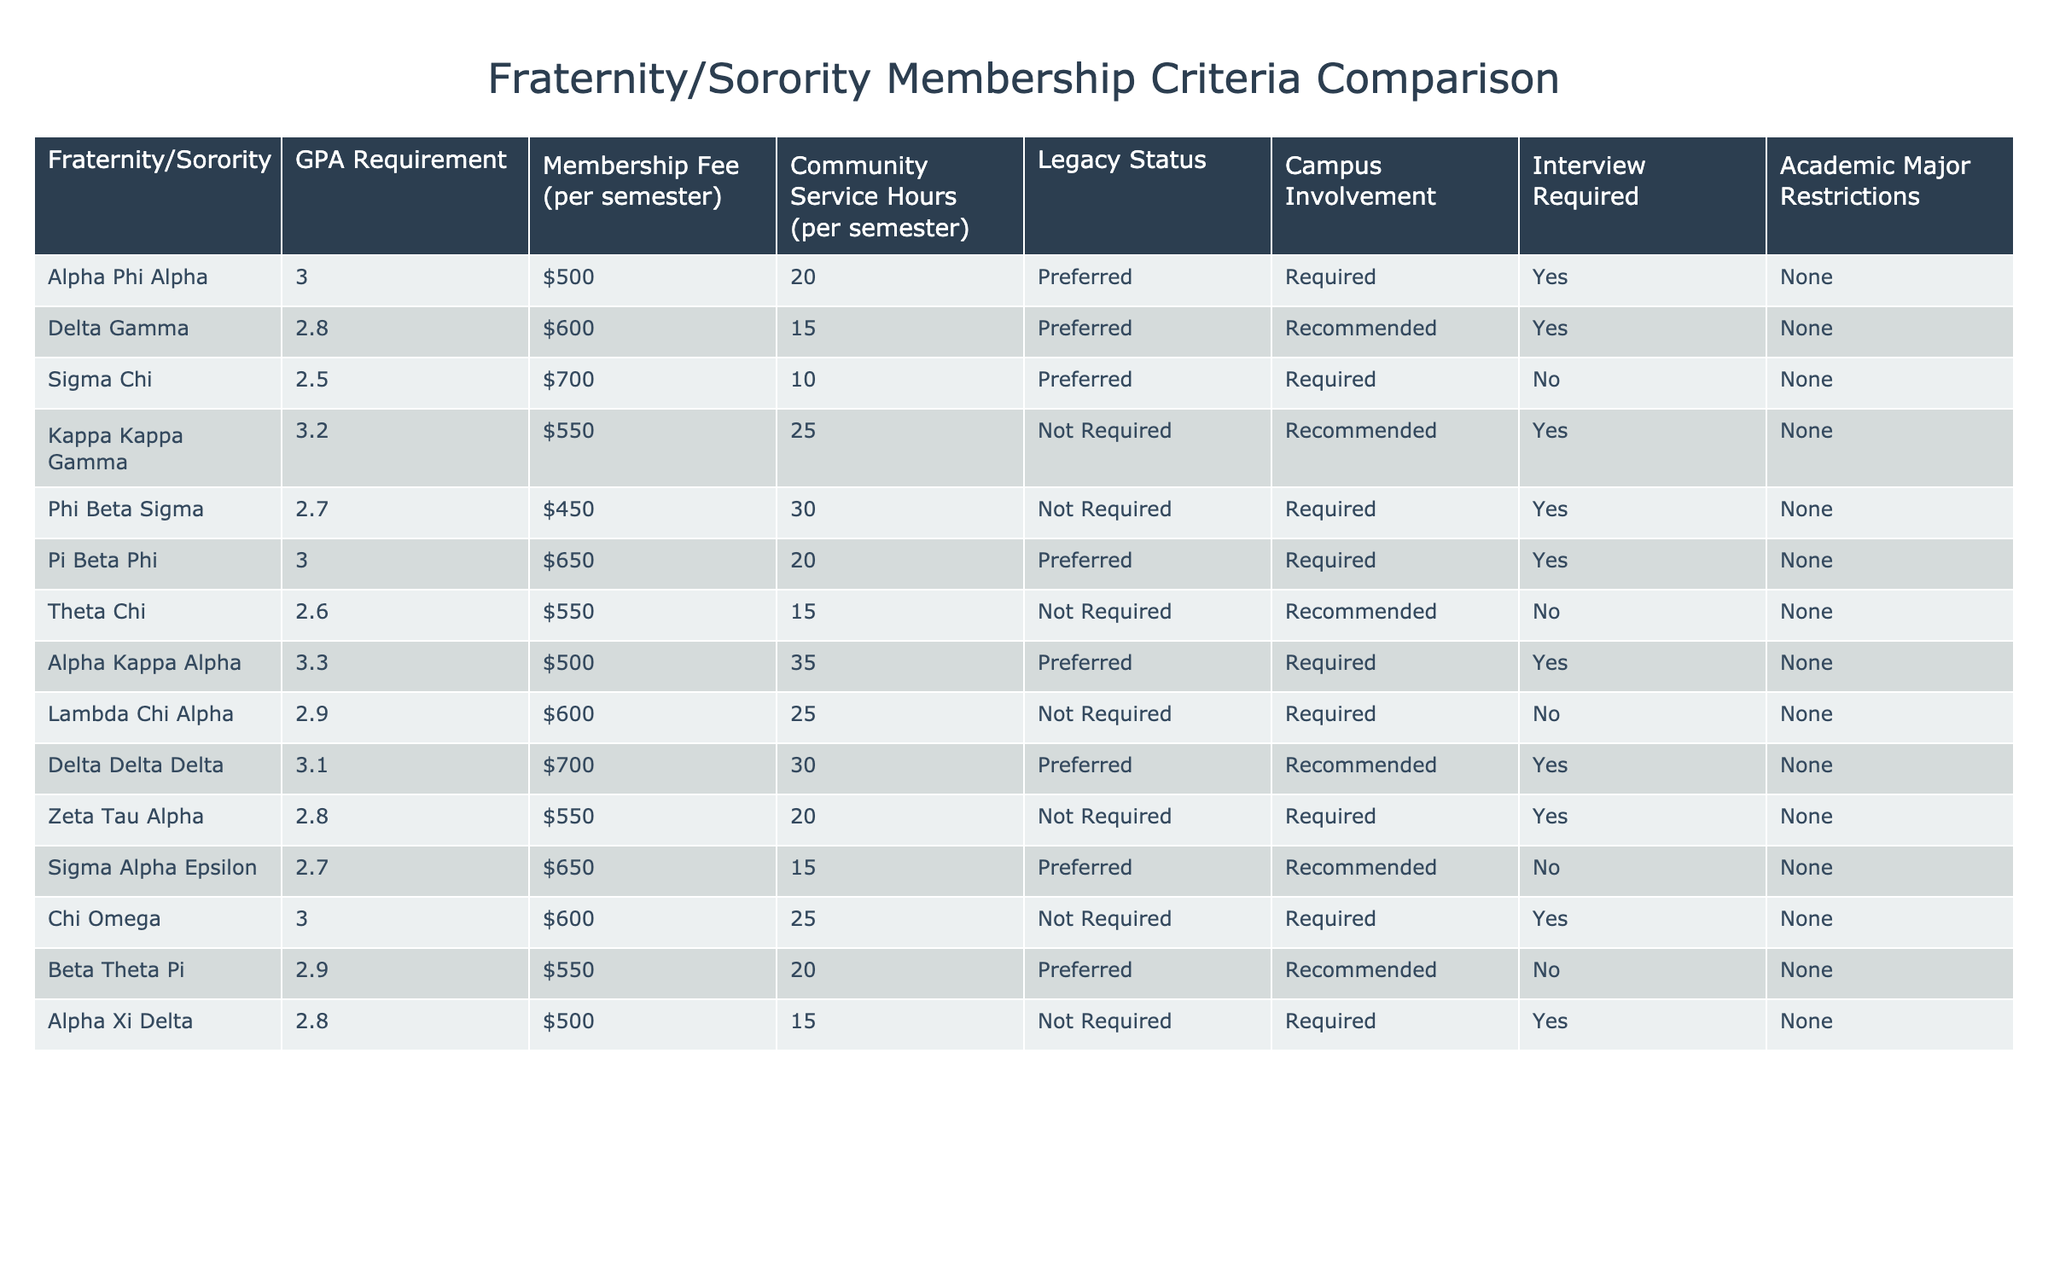What is the GPA requirement for Alpha Kappa Alpha? According to the table, the GPA requirement for Alpha Kappa Alpha is listed directly under the "GPA Requirement" column.
Answer: 3.3 How much is the membership fee for Delta Gamma? The membership fee for Delta Gamma is found in the "Membership Fee (per semester)" column of the table.
Answer: $600 Which fraternity has the lowest GPA requirement? To find the fraternity with the lowest GPA requirement, we can check the "GPA Requirement" column and compare the values. Sigma Chi has the lowest requirement at 2.5.
Answer: Sigma Chi How many community service hours are required by Alpha Xi Delta? By looking at the "Community Service Hours (per semester)" column, we can find the number of hours required for Alpha Xi Delta, which is 15 hours.
Answer: 15 Which fraternity requires an interview and has a GPA requirement of 3.0? We can filter the table for any fraternity that both requires an interview and has a GPA requirement of 3.0. The only fraternity that fits these criteria is Chi Omega.
Answer: Chi Omega What is the average membership fee across all listed fraternities/sororities? First, we need to add together all the membership fees. The fees are: $500, $600, $700, $550, $450, $650, $600, $500, $600, $700, $550, $600, $650, $500 (totaling $8,000). There are 14 organizations, so we calculate the average by dividing $8,000 by 14 which equals approximately $571.43.
Answer: $571.43 Is there a fraternity that does not require an interview and has a GPA requirement below 3.0? We can check the table for fraternities with no interview requirement and a GPA below 3.0. Both Theta Chi (2.6) and Sigma Alpha Epsilon (2.7) meet these conditions.
Answer: Yes What is the maximum number of community service hours required among these organizations? To find the maximum, we compare the values listed under the "Community Service Hours (per semester)" column. The highest value is 35 hours, which is required by Alpha Kappa Alpha.
Answer: 35 How many organizations have a legacy status that is "Preferred"? We can scan the "Legacy Status" column for the number of organizations listed with "Preferred." Upon counting, there are 7 organizations with this status.
Answer: 7 